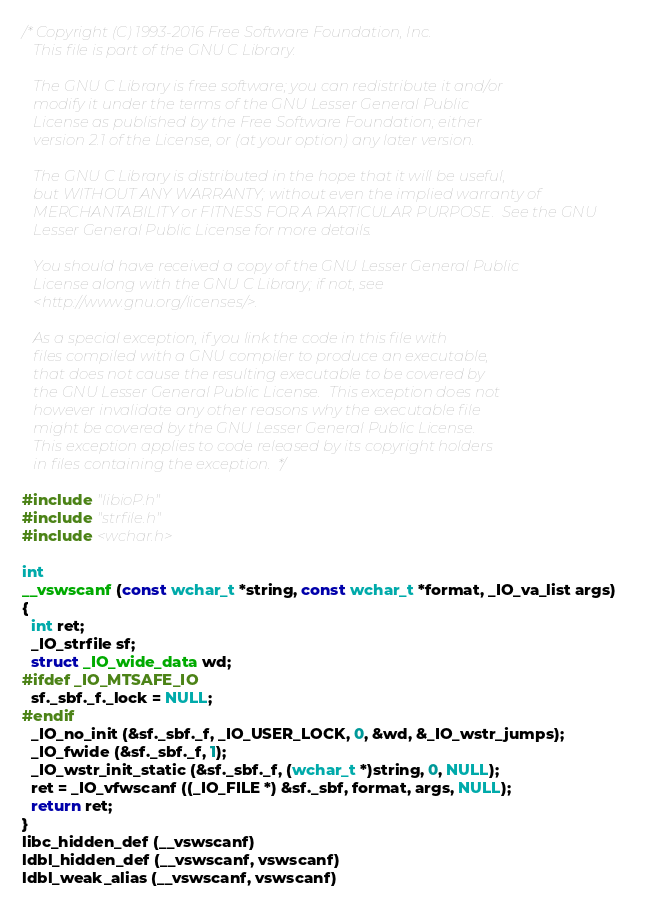Convert code to text. <code><loc_0><loc_0><loc_500><loc_500><_C_>/* Copyright (C) 1993-2016 Free Software Foundation, Inc.
   This file is part of the GNU C Library.

   The GNU C Library is free software; you can redistribute it and/or
   modify it under the terms of the GNU Lesser General Public
   License as published by the Free Software Foundation; either
   version 2.1 of the License, or (at your option) any later version.

   The GNU C Library is distributed in the hope that it will be useful,
   but WITHOUT ANY WARRANTY; without even the implied warranty of
   MERCHANTABILITY or FITNESS FOR A PARTICULAR PURPOSE.  See the GNU
   Lesser General Public License for more details.

   You should have received a copy of the GNU Lesser General Public
   License along with the GNU C Library; if not, see
   <http://www.gnu.org/licenses/>.

   As a special exception, if you link the code in this file with
   files compiled with a GNU compiler to produce an executable,
   that does not cause the resulting executable to be covered by
   the GNU Lesser General Public License.  This exception does not
   however invalidate any other reasons why the executable file
   might be covered by the GNU Lesser General Public License.
   This exception applies to code released by its copyright holders
   in files containing the exception.  */

#include "libioP.h"
#include "strfile.h"
#include <wchar.h>

int
__vswscanf (const wchar_t *string, const wchar_t *format, _IO_va_list args)
{
  int ret;
  _IO_strfile sf;
  struct _IO_wide_data wd;
#ifdef _IO_MTSAFE_IO
  sf._sbf._f._lock = NULL;
#endif
  _IO_no_init (&sf._sbf._f, _IO_USER_LOCK, 0, &wd, &_IO_wstr_jumps);
  _IO_fwide (&sf._sbf._f, 1);
  _IO_wstr_init_static (&sf._sbf._f, (wchar_t *)string, 0, NULL);
  ret = _IO_vfwscanf ((_IO_FILE *) &sf._sbf, format, args, NULL);
  return ret;
}
libc_hidden_def (__vswscanf)
ldbl_hidden_def (__vswscanf, vswscanf)
ldbl_weak_alias (__vswscanf, vswscanf)
</code> 